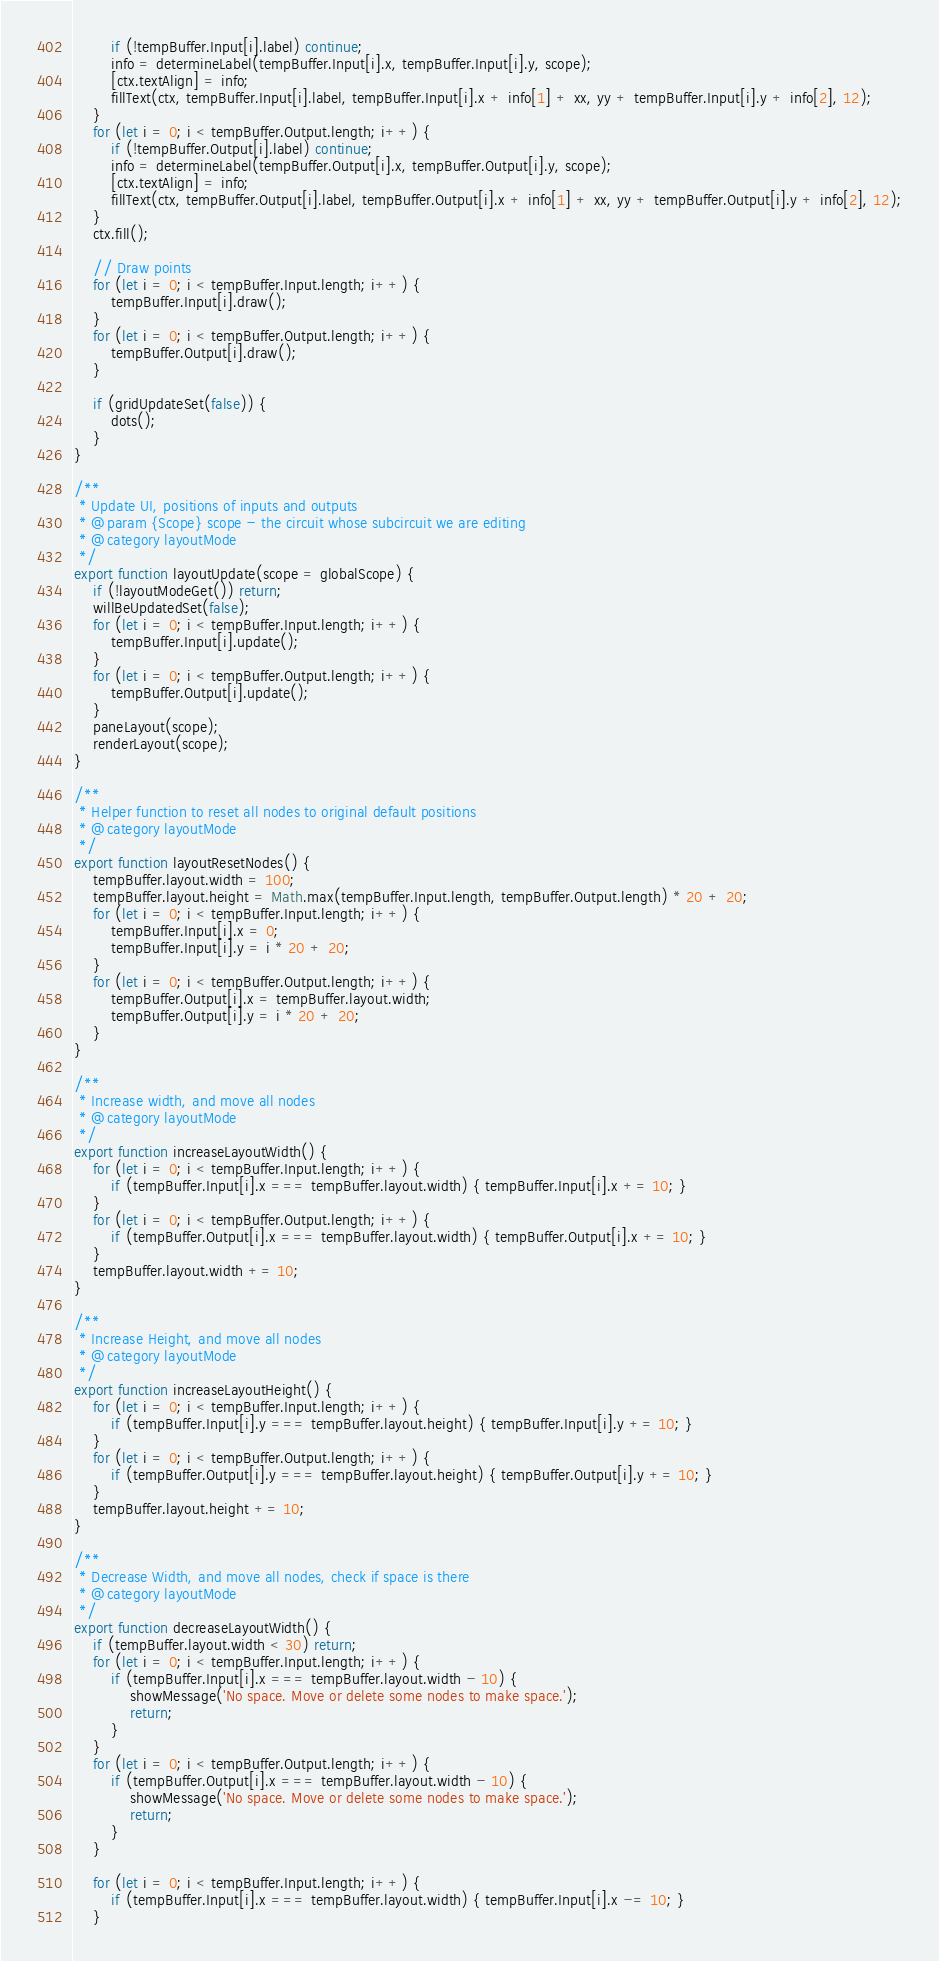Convert code to text. <code><loc_0><loc_0><loc_500><loc_500><_JavaScript_>        if (!tempBuffer.Input[i].label) continue;
        info = determineLabel(tempBuffer.Input[i].x, tempBuffer.Input[i].y, scope);
        [ctx.textAlign] = info;
        fillText(ctx, tempBuffer.Input[i].label, tempBuffer.Input[i].x + info[1] + xx, yy + tempBuffer.Input[i].y + info[2], 12);
    }
    for (let i = 0; i < tempBuffer.Output.length; i++) {
        if (!tempBuffer.Output[i].label) continue;
        info = determineLabel(tempBuffer.Output[i].x, tempBuffer.Output[i].y, scope);
        [ctx.textAlign] = info;
        fillText(ctx, tempBuffer.Output[i].label, tempBuffer.Output[i].x + info[1] + xx, yy + tempBuffer.Output[i].y + info[2], 12);
    }
    ctx.fill();

    // Draw points
    for (let i = 0; i < tempBuffer.Input.length; i++) {
        tempBuffer.Input[i].draw();
    }
    for (let i = 0; i < tempBuffer.Output.length; i++) {
        tempBuffer.Output[i].draw();
    }

    if (gridUpdateSet(false)) {
        dots();
    }
}

/**
 * Update UI, positions of inputs and outputs
 * @param {Scope} scope - the circuit whose subcircuit we are editing
 * @category layoutMode
 */
export function layoutUpdate(scope = globalScope) {
    if (!layoutModeGet()) return;
    willBeUpdatedSet(false);
    for (let i = 0; i < tempBuffer.Input.length; i++) {
        tempBuffer.Input[i].update();
    }
    for (let i = 0; i < tempBuffer.Output.length; i++) {
        tempBuffer.Output[i].update();
    }
    paneLayout(scope);
    renderLayout(scope);
}

/**
 * Helper function to reset all nodes to original default positions
 * @category layoutMode
 */
export function layoutResetNodes() {
    tempBuffer.layout.width = 100;
    tempBuffer.layout.height = Math.max(tempBuffer.Input.length, tempBuffer.Output.length) * 20 + 20;
    for (let i = 0; i < tempBuffer.Input.length; i++) {
        tempBuffer.Input[i].x = 0;
        tempBuffer.Input[i].y = i * 20 + 20;
    }
    for (let i = 0; i < tempBuffer.Output.length; i++) {
        tempBuffer.Output[i].x = tempBuffer.layout.width;
        tempBuffer.Output[i].y = i * 20 + 20;
    }
}

/**
 * Increase width, and move all nodes
 * @category layoutMode
 */
export function increaseLayoutWidth() {
    for (let i = 0; i < tempBuffer.Input.length; i++) {
        if (tempBuffer.Input[i].x === tempBuffer.layout.width) { tempBuffer.Input[i].x += 10; }
    }
    for (let i = 0; i < tempBuffer.Output.length; i++) {
        if (tempBuffer.Output[i].x === tempBuffer.layout.width) { tempBuffer.Output[i].x += 10; }
    }
    tempBuffer.layout.width += 10;
}

/**
 * Increase Height, and move all nodes
 * @category layoutMode
 */
export function increaseLayoutHeight() {
    for (let i = 0; i < tempBuffer.Input.length; i++) {
        if (tempBuffer.Input[i].y === tempBuffer.layout.height) { tempBuffer.Input[i].y += 10; }
    }
    for (let i = 0; i < tempBuffer.Output.length; i++) {
        if (tempBuffer.Output[i].y === tempBuffer.layout.height) { tempBuffer.Output[i].y += 10; }
    }
    tempBuffer.layout.height += 10;
}

/**
 * Decrease Width, and move all nodes, check if space is there
 * @category layoutMode
 */
export function decreaseLayoutWidth() {
    if (tempBuffer.layout.width < 30) return;
    for (let i = 0; i < tempBuffer.Input.length; i++) {
        if (tempBuffer.Input[i].x === tempBuffer.layout.width - 10) {
            showMessage('No space. Move or delete some nodes to make space.');
            return;
        }
    }
    for (let i = 0; i < tempBuffer.Output.length; i++) {
        if (tempBuffer.Output[i].x === tempBuffer.layout.width - 10) {
            showMessage('No space. Move or delete some nodes to make space.');
            return;
        }
    }

    for (let i = 0; i < tempBuffer.Input.length; i++) {
        if (tempBuffer.Input[i].x === tempBuffer.layout.width) { tempBuffer.Input[i].x -= 10; }
    }</code> 